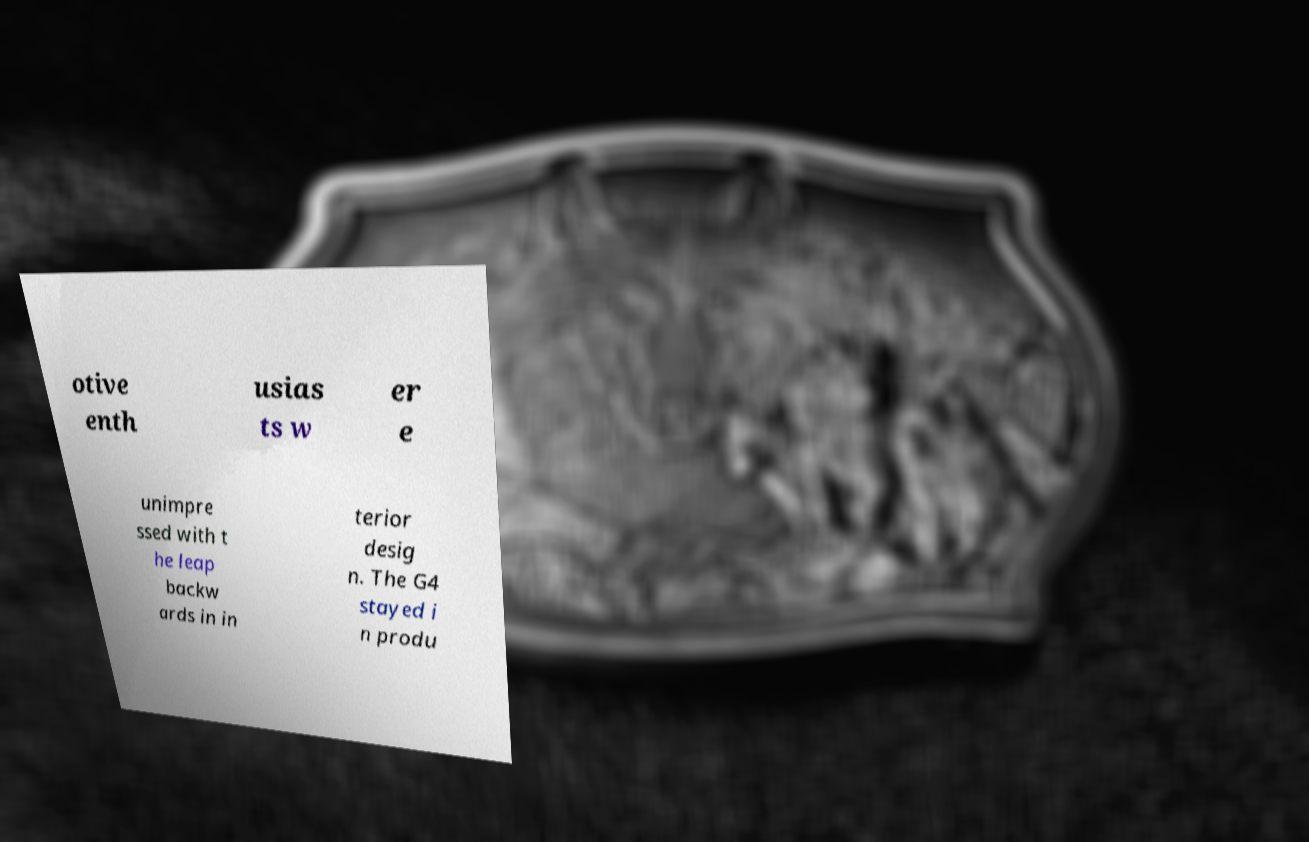For documentation purposes, I need the text within this image transcribed. Could you provide that? otive enth usias ts w er e unimpre ssed with t he leap backw ards in in terior desig n. The G4 stayed i n produ 